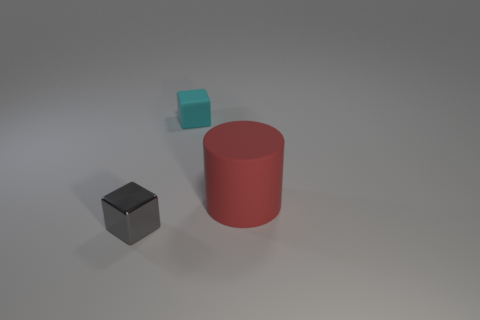Are there any other things that have the same material as the small gray cube?
Offer a very short reply. No. There is a small thing on the left side of the cyan matte cube; does it have the same shape as the large matte thing?
Your response must be concise. No. Is the number of large purple metal cylinders less than the number of tiny cyan rubber cubes?
Provide a short and direct response. Yes. How many tiny rubber blocks have the same color as the cylinder?
Offer a very short reply. 0. Is the color of the tiny rubber object the same as the thing that is in front of the large red cylinder?
Your answer should be very brief. No. Are there more big rubber cylinders than yellow shiny cubes?
Your answer should be compact. Yes. The other cyan thing that is the same shape as the shiny thing is what size?
Provide a short and direct response. Small. Is the material of the tiny cyan thing the same as the block that is in front of the big red rubber cylinder?
Ensure brevity in your answer.  No. How many objects are either large green cylinders or small things?
Your answer should be very brief. 2. There is a thing that is on the right side of the tiny cyan object; does it have the same size as the cube on the right side of the gray shiny cube?
Your response must be concise. No. 